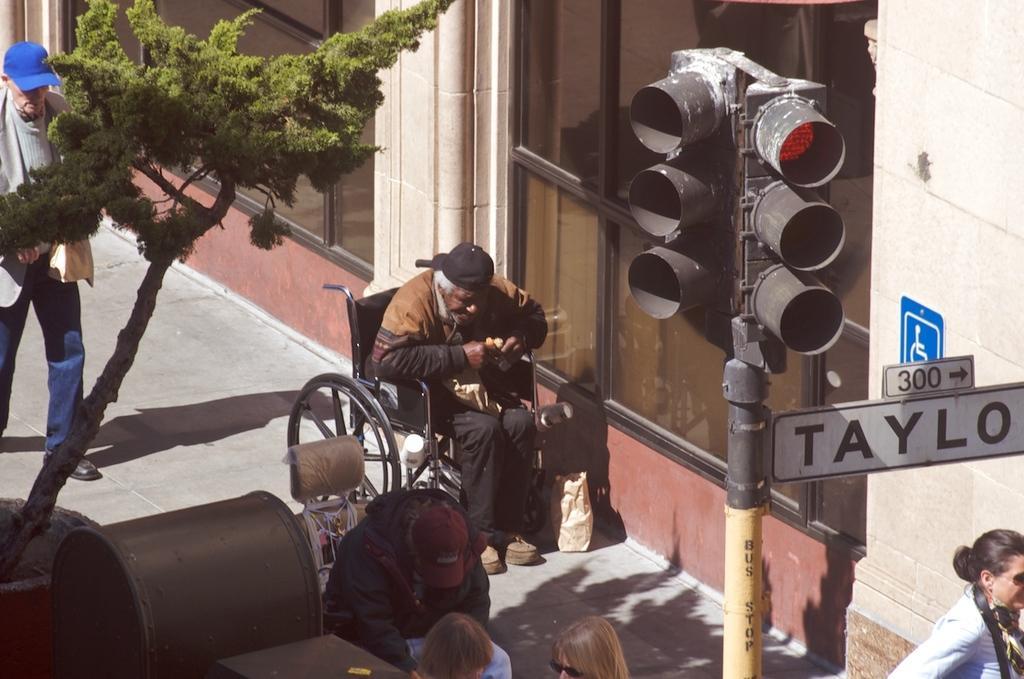Please provide a concise description of this image. In this image we can see people, some of them are sitting on the chairs, on persons is eating food, beside him there is a bag, a person with blue cap is holding a bag and walking on the ground, there are some traffic lights, sign boards, also we can see a building and windows, and left corner of the image we can see some objects. 